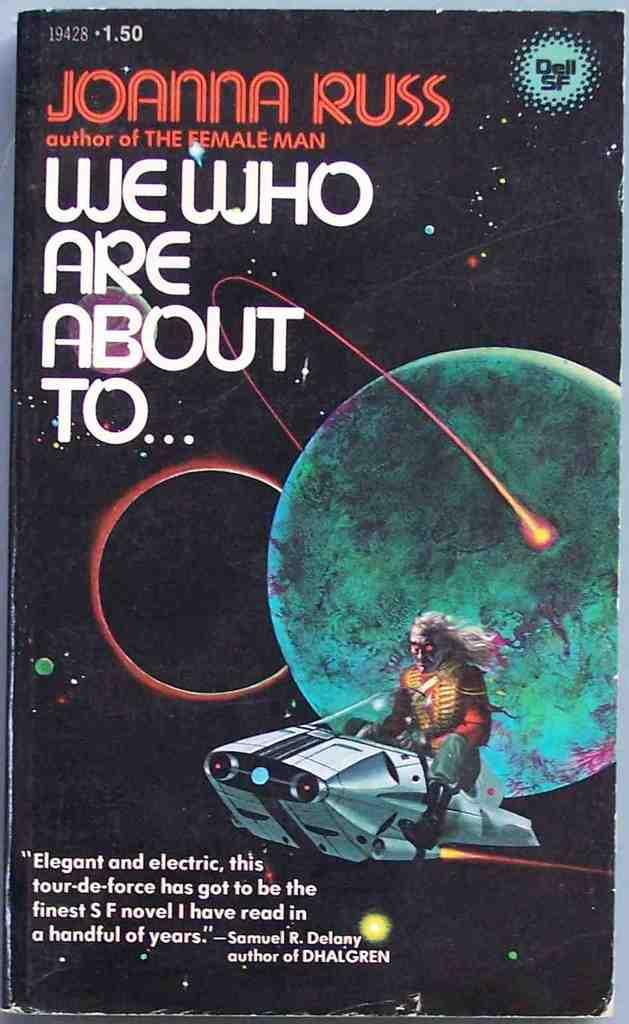<image>
Describe the image concisely. Joanna Russ wrote two books including "We Who are About to," 